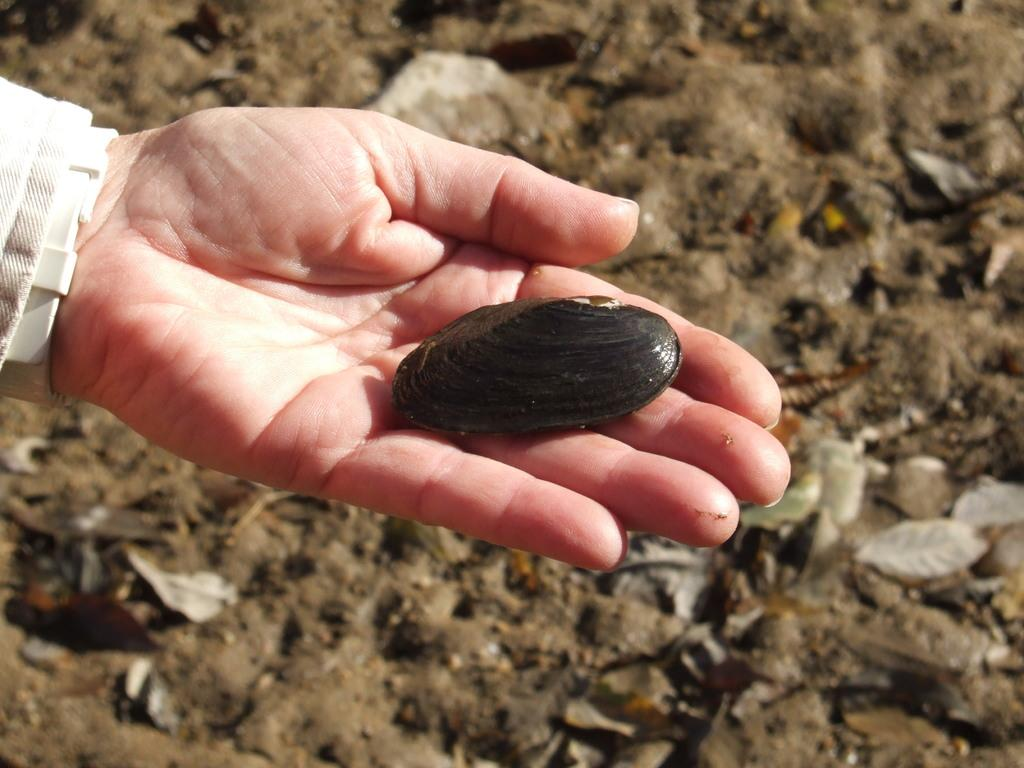What object is being held by a person in the image? There is a shell in the image, and it is being held by a person. What type of natural elements can be seen in the image? Leaves and sand are visible in the image. What type of attraction can be seen in the image? There is no attraction present in the image; it features a shell being held by a person, leaves, and sand. Is there a hole in the image? There is no hole mentioned or visible in the image. 